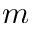<formula> <loc_0><loc_0><loc_500><loc_500>m</formula> 